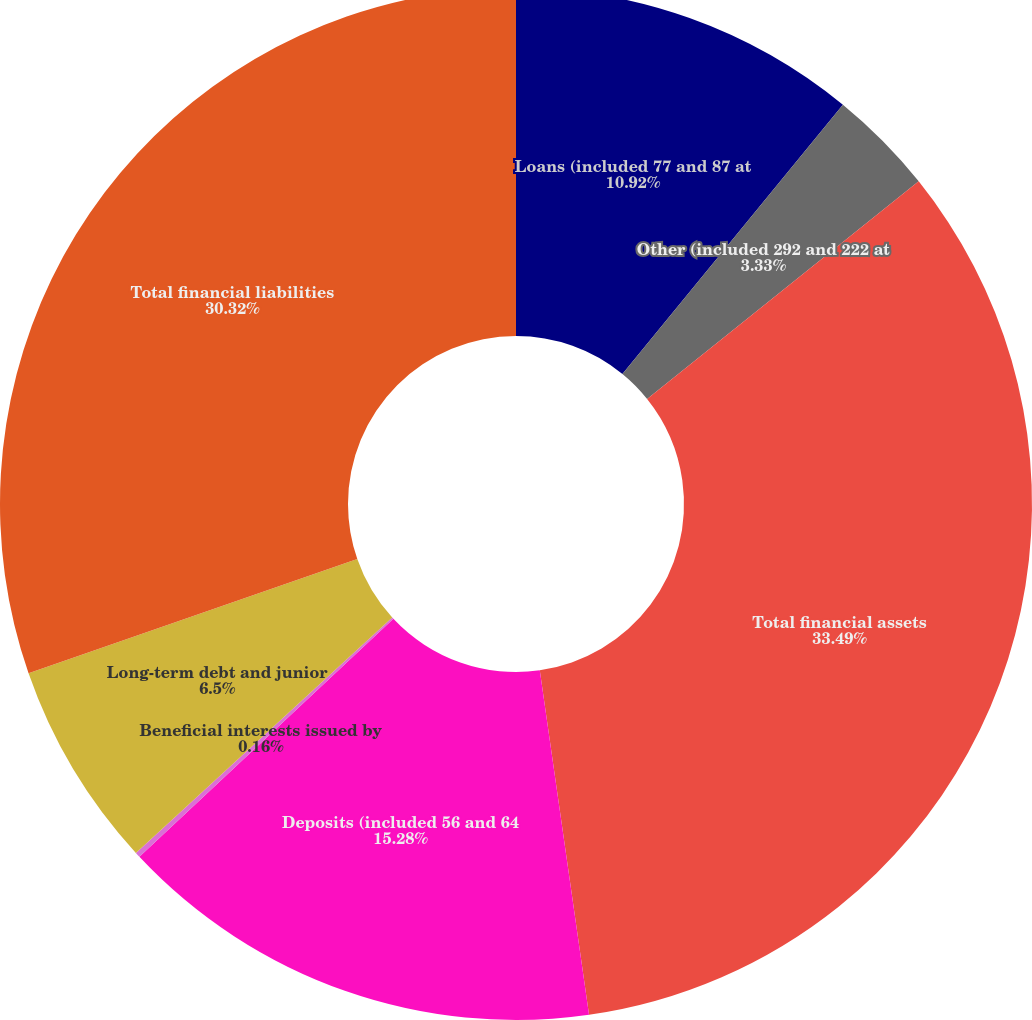Convert chart. <chart><loc_0><loc_0><loc_500><loc_500><pie_chart><fcel>Loans (included 77 and 87 at<fcel>Other (included 292 and 222 at<fcel>Total financial assets<fcel>Deposits (included 56 and 64<fcel>Beneficial interests issued by<fcel>Long-term debt and junior<fcel>Total financial liabilities<nl><fcel>10.92%<fcel>3.33%<fcel>33.49%<fcel>15.28%<fcel>0.16%<fcel>6.5%<fcel>30.32%<nl></chart> 